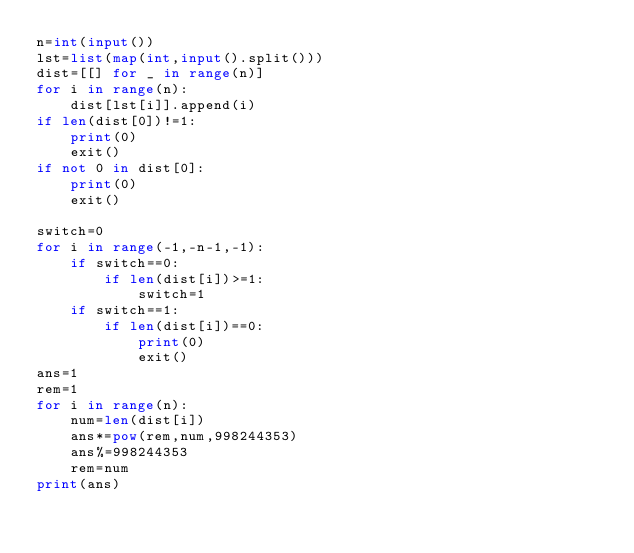<code> <loc_0><loc_0><loc_500><loc_500><_Python_>n=int(input())
lst=list(map(int,input().split()))
dist=[[] for _ in range(n)]
for i in range(n):
    dist[lst[i]].append(i)
if len(dist[0])!=1:
    print(0)
    exit()
if not 0 in dist[0]:
    print(0)
    exit()

switch=0
for i in range(-1,-n-1,-1):
    if switch==0:
        if len(dist[i])>=1:
            switch=1
    if switch==1:
        if len(dist[i])==0:
            print(0)
            exit()
ans=1
rem=1
for i in range(n):
    num=len(dist[i])
    ans*=pow(rem,num,998244353)
    ans%=998244353
    rem=num
print(ans)</code> 